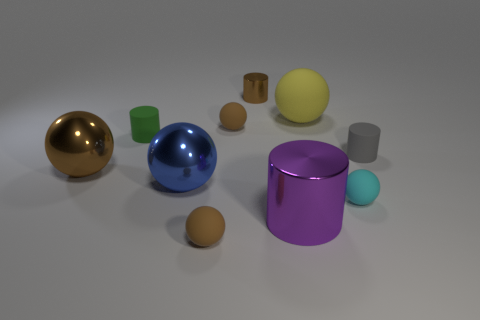Subtract all tiny cylinders. How many cylinders are left? 1 Subtract all gray blocks. How many brown balls are left? 3 Subtract 1 spheres. How many spheres are left? 5 Subtract all gray cylinders. How many cylinders are left? 3 Subtract all spheres. How many objects are left? 4 Subtract all green balls. Subtract all purple cylinders. How many balls are left? 6 Subtract all small red matte cylinders. Subtract all brown cylinders. How many objects are left? 9 Add 7 tiny brown matte objects. How many tiny brown matte objects are left? 9 Add 7 large brown spheres. How many large brown spheres exist? 8 Subtract 0 gray spheres. How many objects are left? 10 